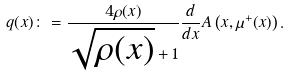Convert formula to latex. <formula><loc_0><loc_0><loc_500><loc_500>q ( x ) \colon = \frac { 4 \rho ( x ) } { \sqrt { \rho ( x ) } + 1 } \frac { d } { d x } A \left ( x , \mu ^ { + } ( x ) \right ) .</formula> 